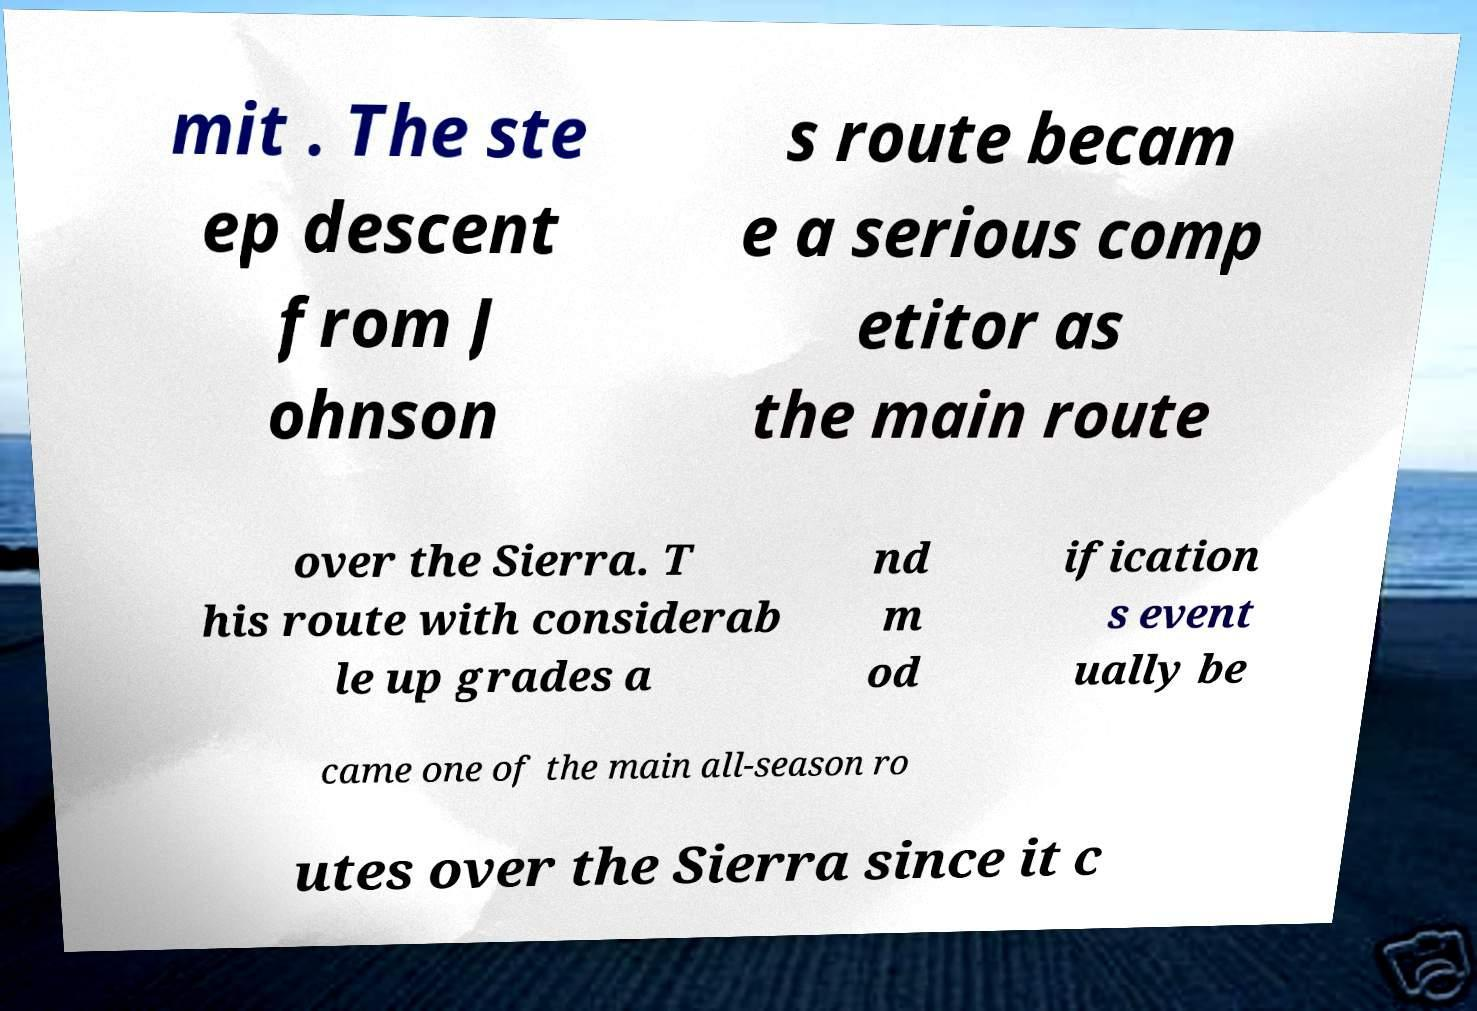Could you assist in decoding the text presented in this image and type it out clearly? mit . The ste ep descent from J ohnson s route becam e a serious comp etitor as the main route over the Sierra. T his route with considerab le up grades a nd m od ification s event ually be came one of the main all-season ro utes over the Sierra since it c 